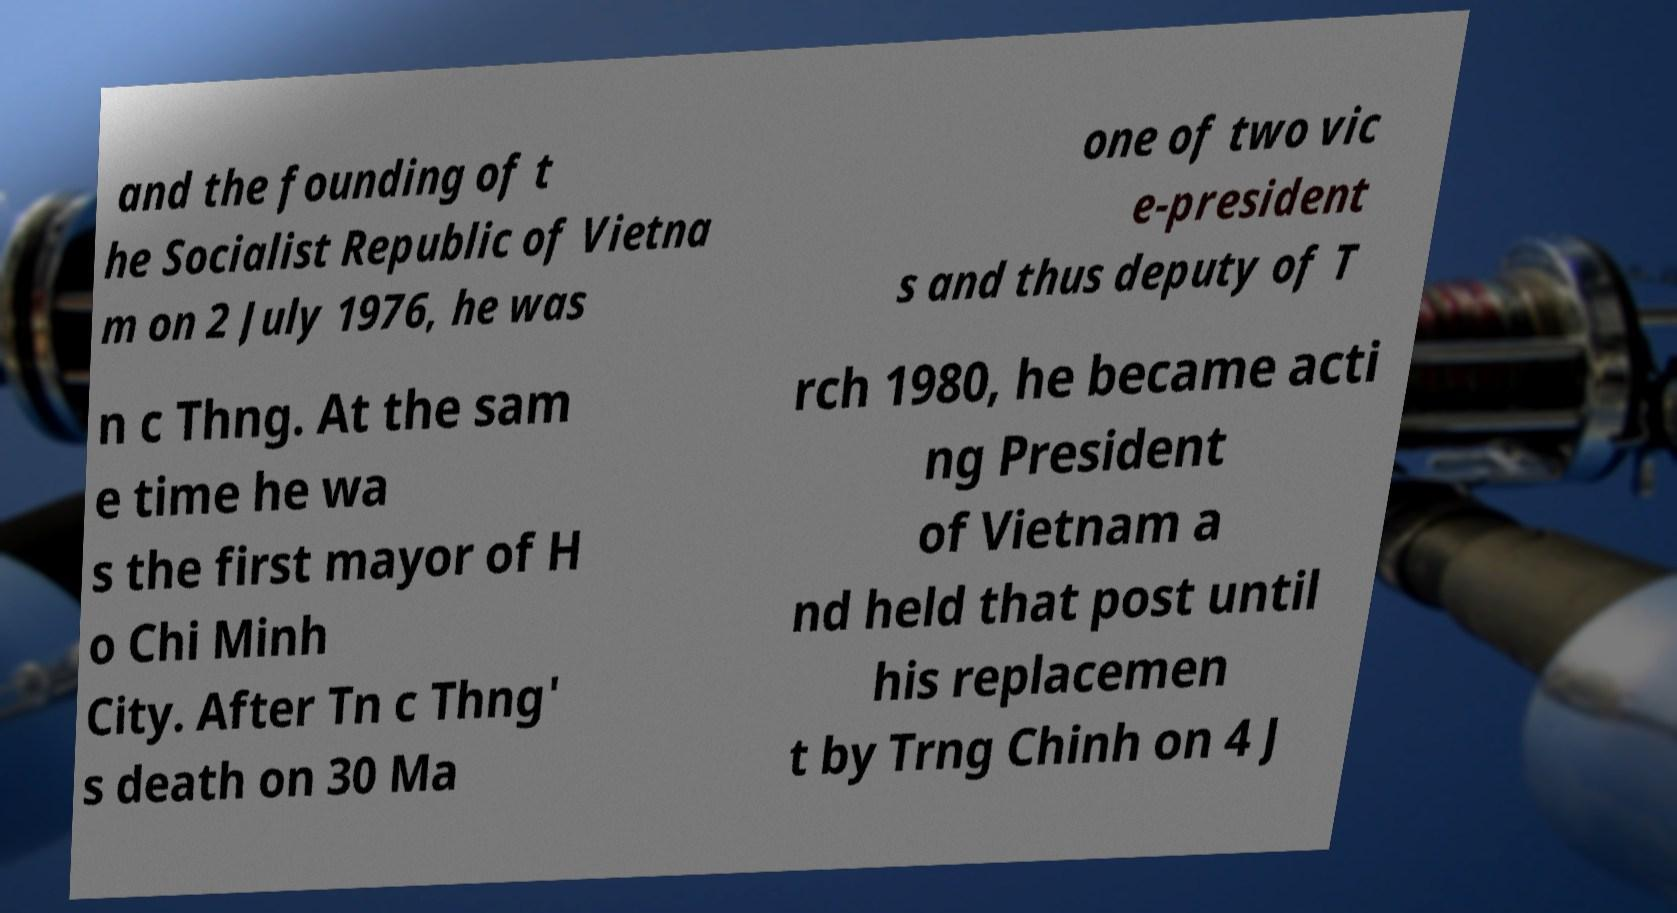Could you extract and type out the text from this image? and the founding of t he Socialist Republic of Vietna m on 2 July 1976, he was one of two vic e-president s and thus deputy of T n c Thng. At the sam e time he wa s the first mayor of H o Chi Minh City. After Tn c Thng' s death on 30 Ma rch 1980, he became acti ng President of Vietnam a nd held that post until his replacemen t by Trng Chinh on 4 J 